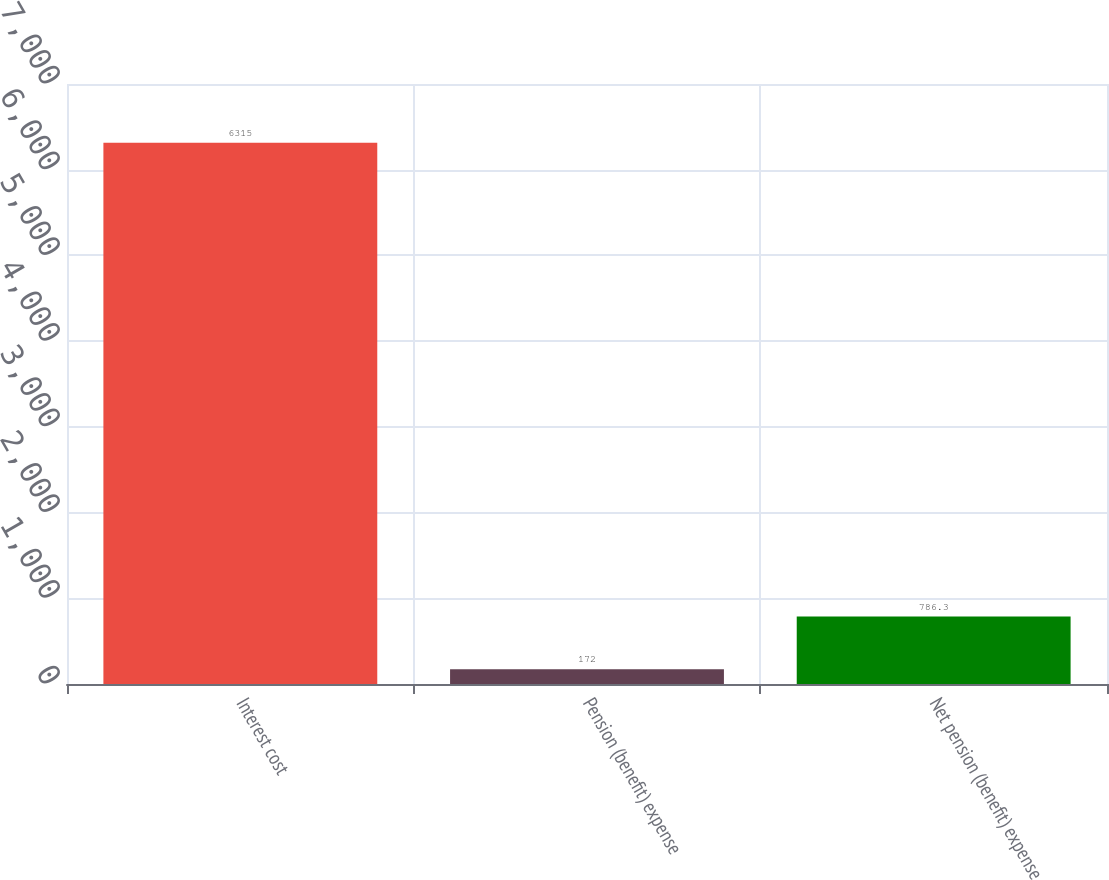Convert chart. <chart><loc_0><loc_0><loc_500><loc_500><bar_chart><fcel>Interest cost<fcel>Pension (benefit) expense<fcel>Net pension (benefit) expense<nl><fcel>6315<fcel>172<fcel>786.3<nl></chart> 